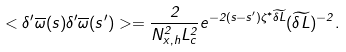Convert formula to latex. <formula><loc_0><loc_0><loc_500><loc_500>< \delta ^ { \prime } \overline { \omega } ( s ) \delta ^ { \prime } \overline { \omega } ( s ^ { \prime } ) > = \frac { 2 } { N _ { x , h } ^ { 2 } L _ { c } ^ { 2 } } e ^ { - 2 ( s - s ^ { \prime } ) \zeta ^ { * } \widetilde { \delta L } } ( \widetilde { \delta L } ) ^ { - 2 } .</formula> 